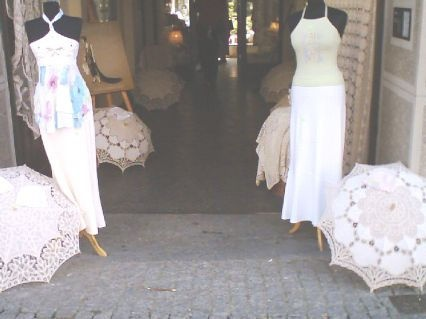Describe the objects in this image and their specific colors. I can see people in gray, white, darkgray, and lightgray tones, umbrella in gray, lavender, and darkgray tones, umbrella in gray, lavender, darkgray, and lightgray tones, umbrella in gray, darkgray, and lightgray tones, and people in gray, beige, lightgray, and olive tones in this image. 